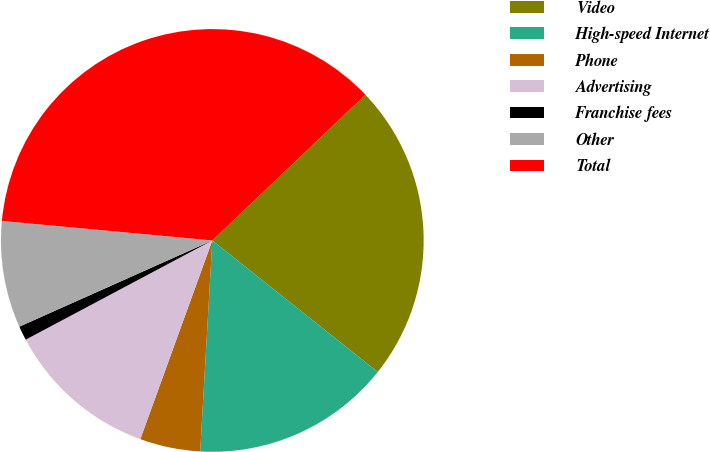Convert chart. <chart><loc_0><loc_0><loc_500><loc_500><pie_chart><fcel>Video<fcel>High-speed Internet<fcel>Phone<fcel>Advertising<fcel>Franchise fees<fcel>Other<fcel>Total<nl><fcel>22.8%<fcel>15.22%<fcel>4.62%<fcel>11.69%<fcel>1.09%<fcel>8.16%<fcel>36.42%<nl></chart> 